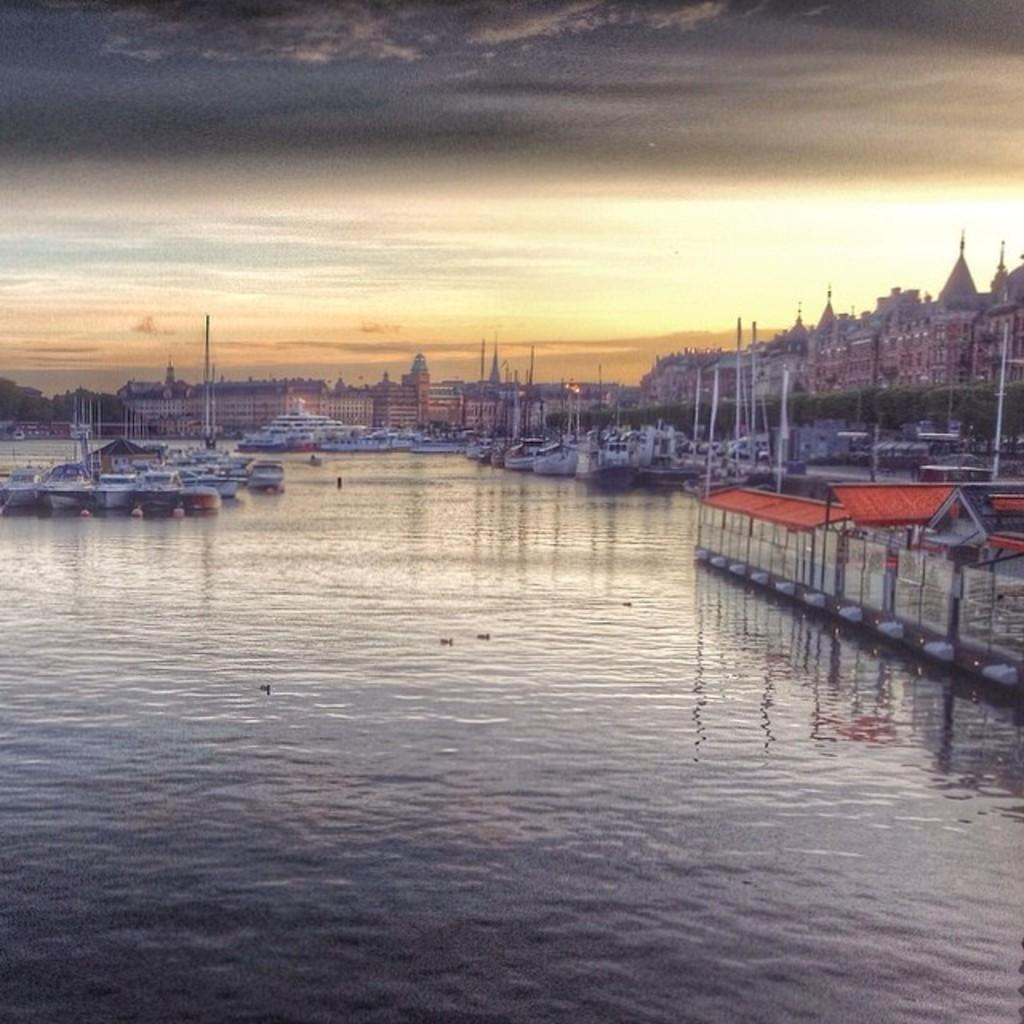What is in the water in the image? There are boats in the water in the image. What can be seen in the background of the image? There are buildings and clouds visible in the background. What part of the natural environment is visible in the image? The sky is visible in the background of the image. Can you see any brushes in the image? There are no brushes present in the image. Are there any clams visible in the water? There are no clams visible in the water; the image only shows boats. 